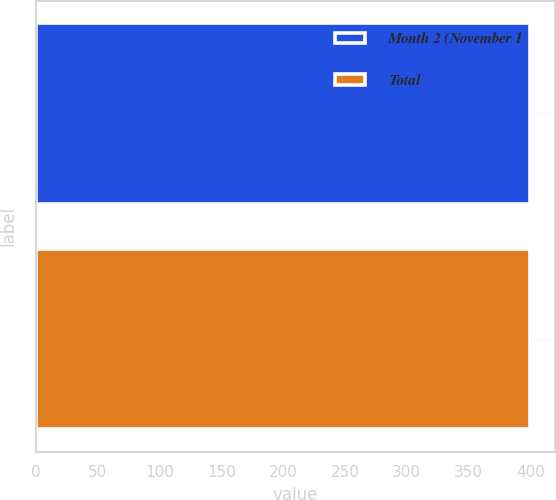Convert chart. <chart><loc_0><loc_0><loc_500><loc_500><bar_chart><fcel>Month 2 (November 1<fcel>Total<nl><fcel>400<fcel>400.1<nl></chart> 